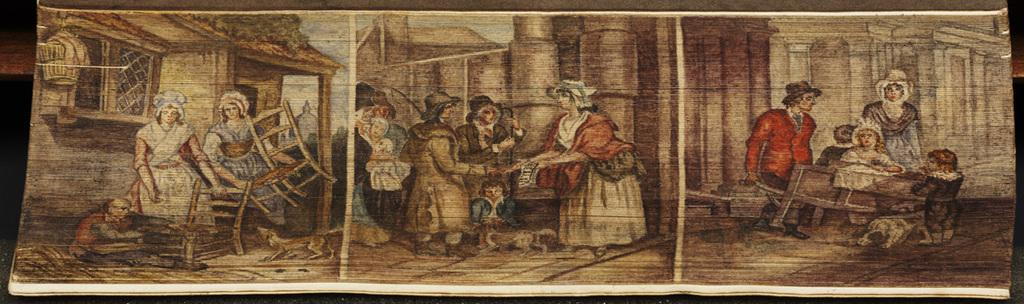What is featured in the image? There is a poster in the image. What can be found on the poster? The poster contains paintings. What subjects are depicted in the paintings? The paintings depict persons, chairs, dogs, houses, walls, and floors. What type of beef is being served in the image? There is no beef present in the image; it features a poster with paintings. How many pickles can be seen in the image? There are no pickles present in the image. 